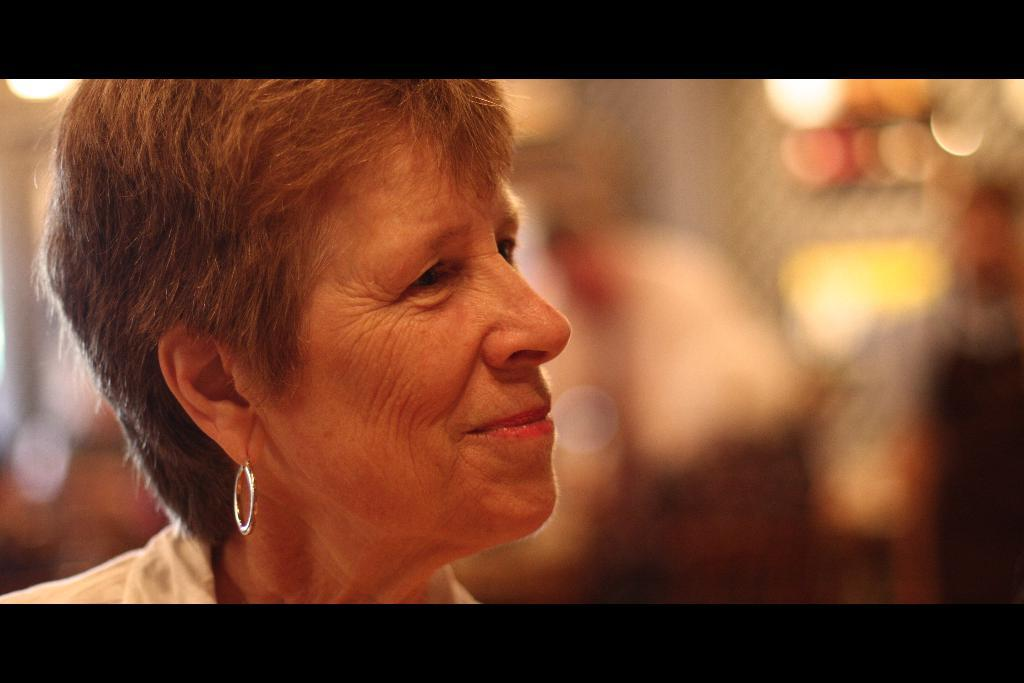Who is present in the image? There is a woman in the image. What is the woman's facial expression? The woman is smiling. What type of accessory is the woman wearing? The woman is wearing an earring. What type of nut can be seen in the woman's hand in the image? There is no nut present in the image; the woman is not holding anything in her hand. 